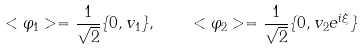Convert formula to latex. <formula><loc_0><loc_0><loc_500><loc_500>< \varphi _ { 1 } > = \frac { 1 } { \sqrt { 2 } } \{ 0 , v _ { 1 } \} , \quad < \varphi _ { 2 } > = \frac { 1 } { \sqrt { 2 } } \{ 0 , v _ { 2 } e ^ { i \xi } \}</formula> 